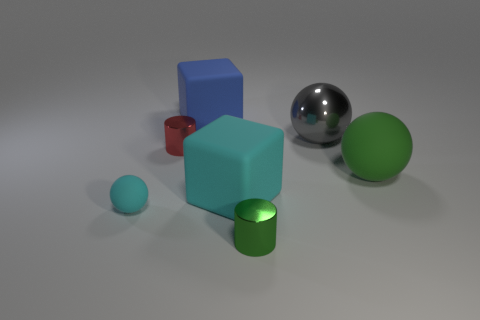Add 1 large blue blocks. How many objects exist? 8 Subtract all balls. How many objects are left? 4 Subtract 0 red balls. How many objects are left? 7 Subtract all large cyan things. Subtract all small matte objects. How many objects are left? 5 Add 4 red things. How many red things are left? 5 Add 5 large blue blocks. How many large blue blocks exist? 6 